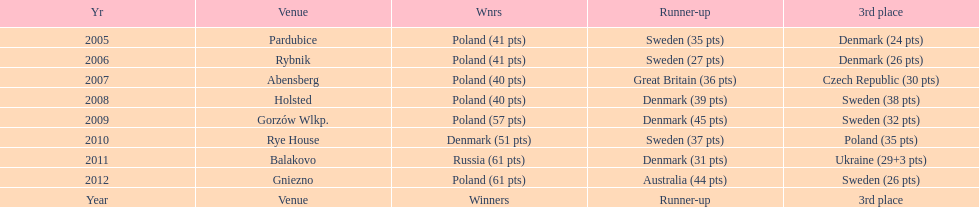Before 2008, how many times was sweden the second-place finisher? 2. 